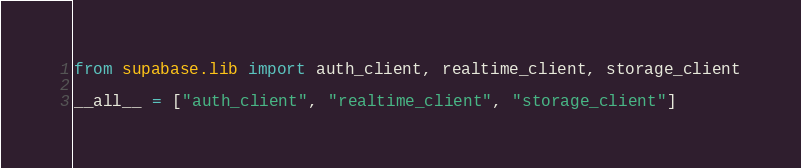<code> <loc_0><loc_0><loc_500><loc_500><_Python_>from supabase.lib import auth_client, realtime_client, storage_client

__all__ = ["auth_client", "realtime_client", "storage_client"]
</code> 